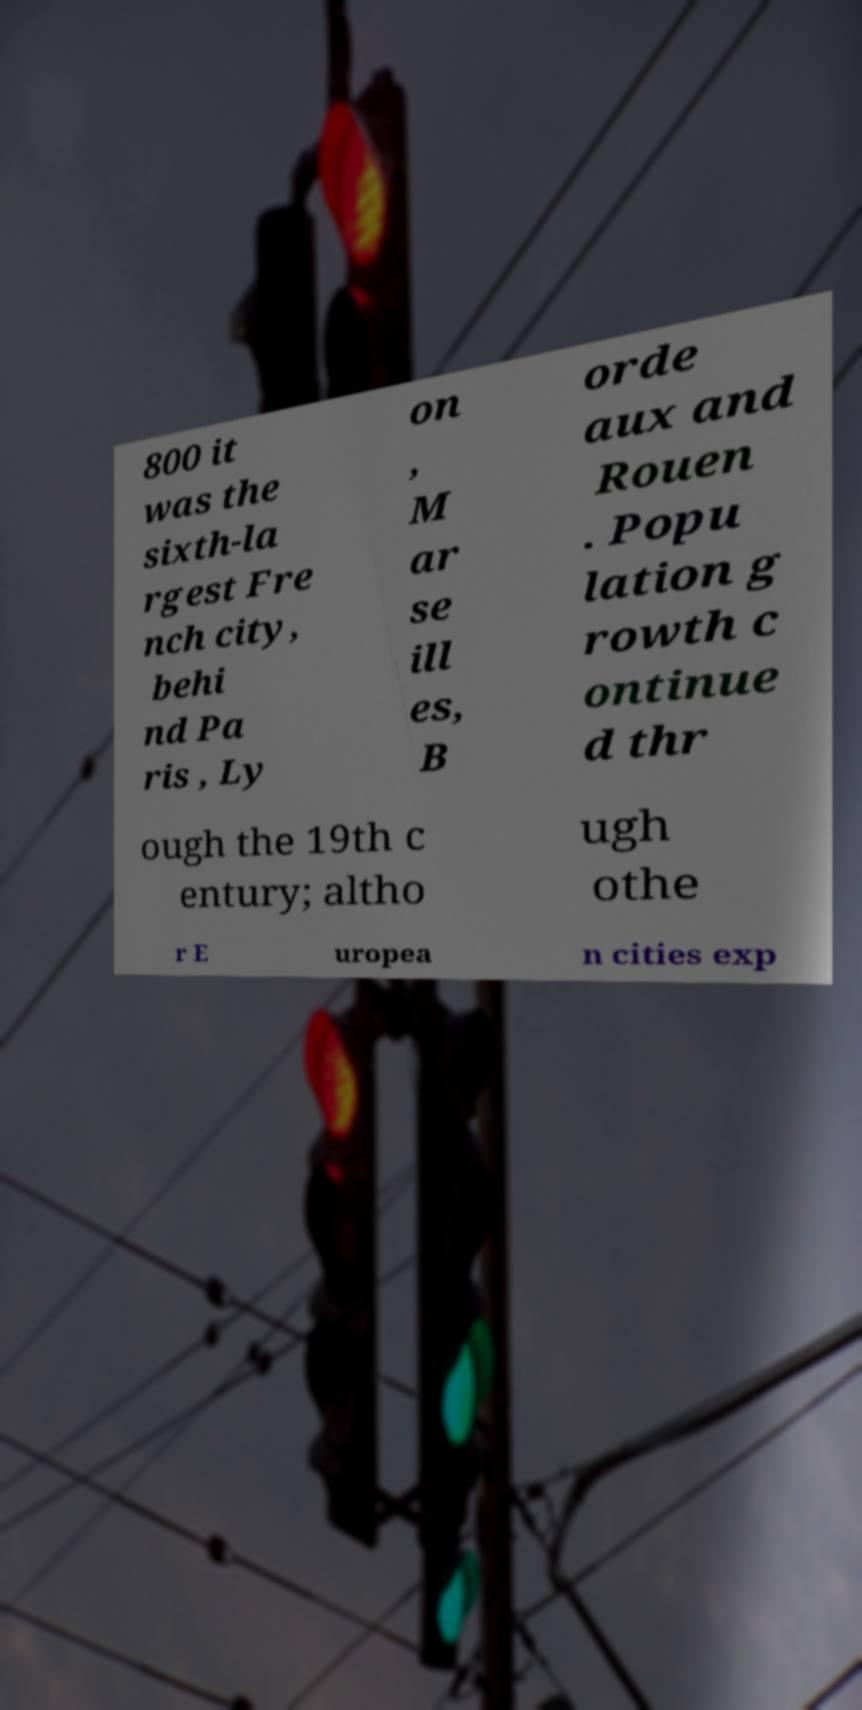For documentation purposes, I need the text within this image transcribed. Could you provide that? 800 it was the sixth-la rgest Fre nch city, behi nd Pa ris , Ly on , M ar se ill es, B orde aux and Rouen . Popu lation g rowth c ontinue d thr ough the 19th c entury; altho ugh othe r E uropea n cities exp 